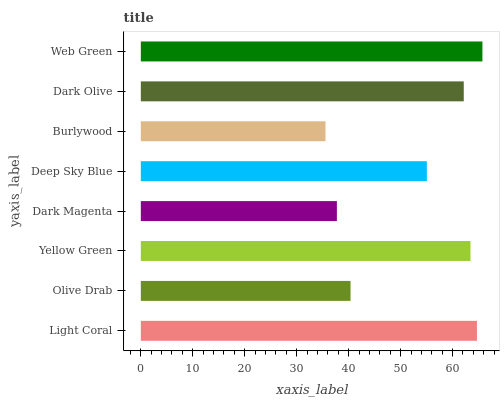Is Burlywood the minimum?
Answer yes or no. Yes. Is Web Green the maximum?
Answer yes or no. Yes. Is Olive Drab the minimum?
Answer yes or no. No. Is Olive Drab the maximum?
Answer yes or no. No. Is Light Coral greater than Olive Drab?
Answer yes or no. Yes. Is Olive Drab less than Light Coral?
Answer yes or no. Yes. Is Olive Drab greater than Light Coral?
Answer yes or no. No. Is Light Coral less than Olive Drab?
Answer yes or no. No. Is Dark Olive the high median?
Answer yes or no. Yes. Is Deep Sky Blue the low median?
Answer yes or no. Yes. Is Dark Magenta the high median?
Answer yes or no. No. Is Light Coral the low median?
Answer yes or no. No. 